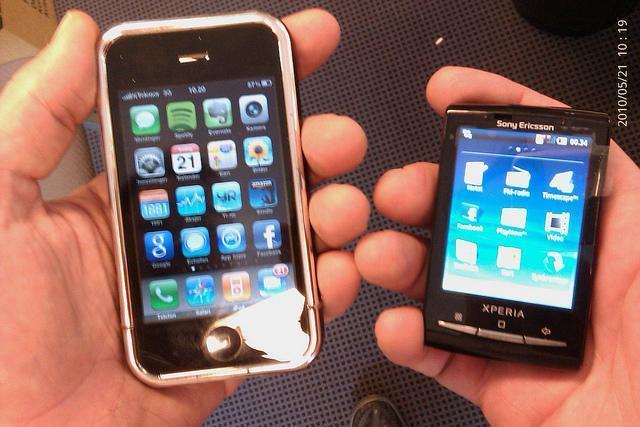How many people are there?
Give a very brief answer. 3. How many cell phones can you see?
Give a very brief answer. 2. 